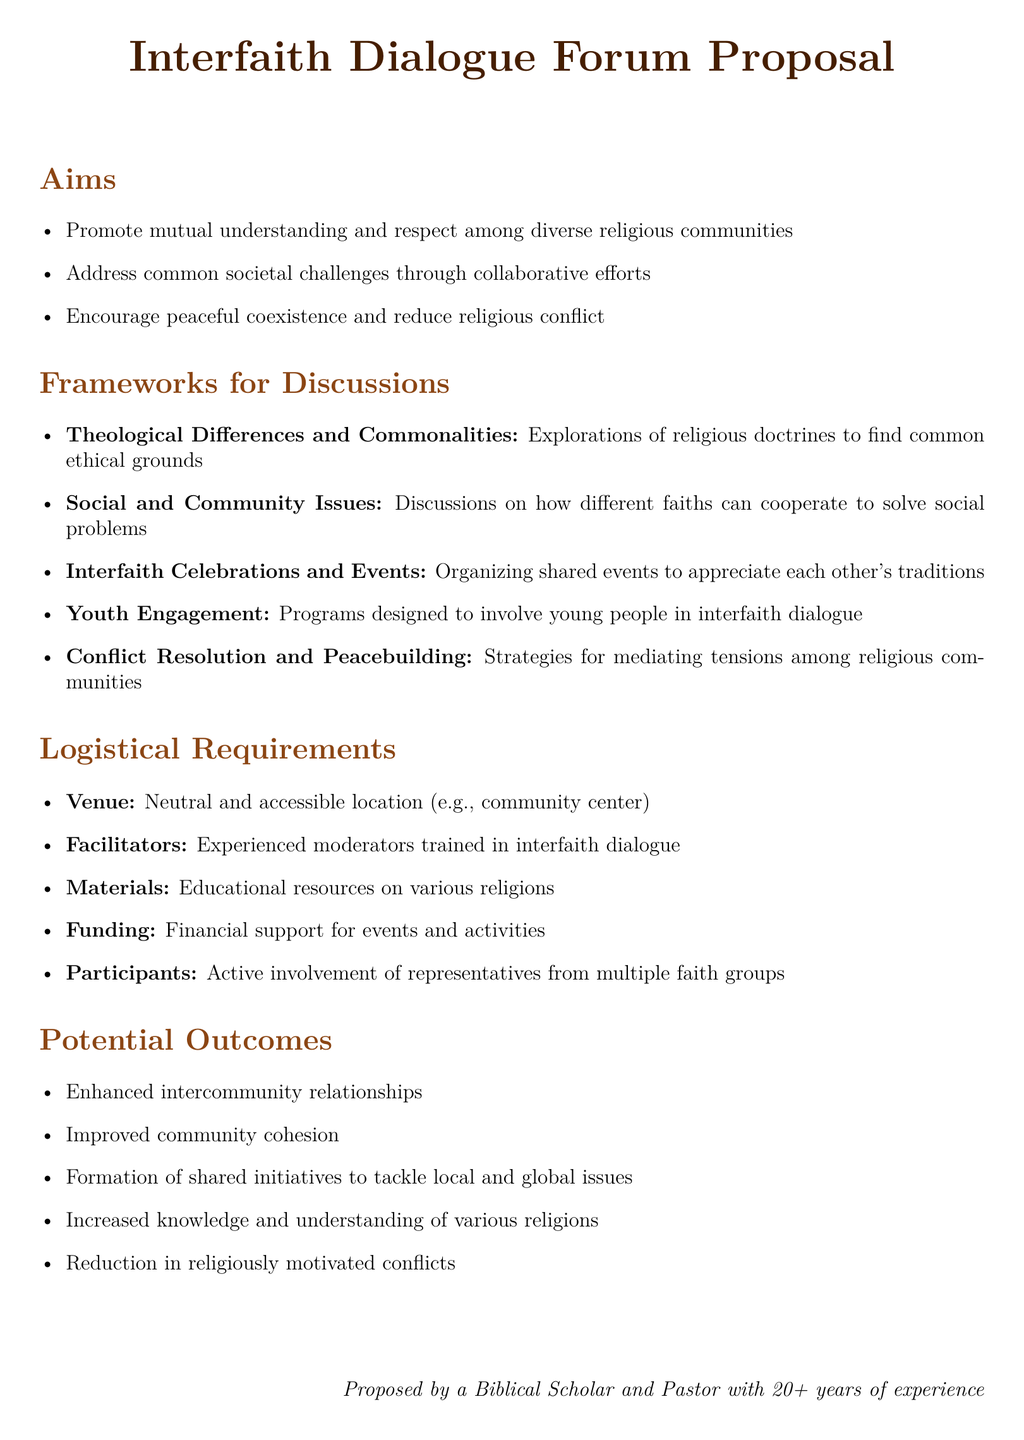What is the main aim of the interfaith dialogue forum? The main aim of the forum is to promote mutual understanding and respect among diverse religious communities.
Answer: Promote mutual understanding and respect among diverse religious communities What is one of the frameworks for discussions mentioned? The document lists several frameworks for discussions, one of which focuses on 'Theological Differences and Commonalities.'
Answer: Theological Differences and Commonalities How many potential outcomes are listed in the proposal? The proposal outlines five potential outcomes that are expected from the initiative.
Answer: Five What type of venue is required for the forum? The logistical requirements mention a neutral and accessible location, such as a community center.
Answer: Neutral and accessible location (e.g., community center) Who proposed the interfaith dialogue forum? The proposal indicates that a biblical scholar and pastor with over 20 years of experience is the proposer.
Answer: A Biblical Scholar and Pastor with 20+ years of experience What is one logistical requirement related to participants? The document specifies that active involvement of representatives from multiple faith groups is necessary for the forum.
Answer: Active involvement of representatives from multiple faith groups Which framework emphasizes youth involvement? The proposal explicitly mentions 'Youth Engagement' as a framework designed to involve young people in interfaith dialogue.
Answer: Youth Engagement What is one desired outcome related to community issues? The proposal states that a desired outcome is the formation of shared initiatives to tackle local and global issues.
Answer: Formation of shared initiatives to tackle local and global issues 